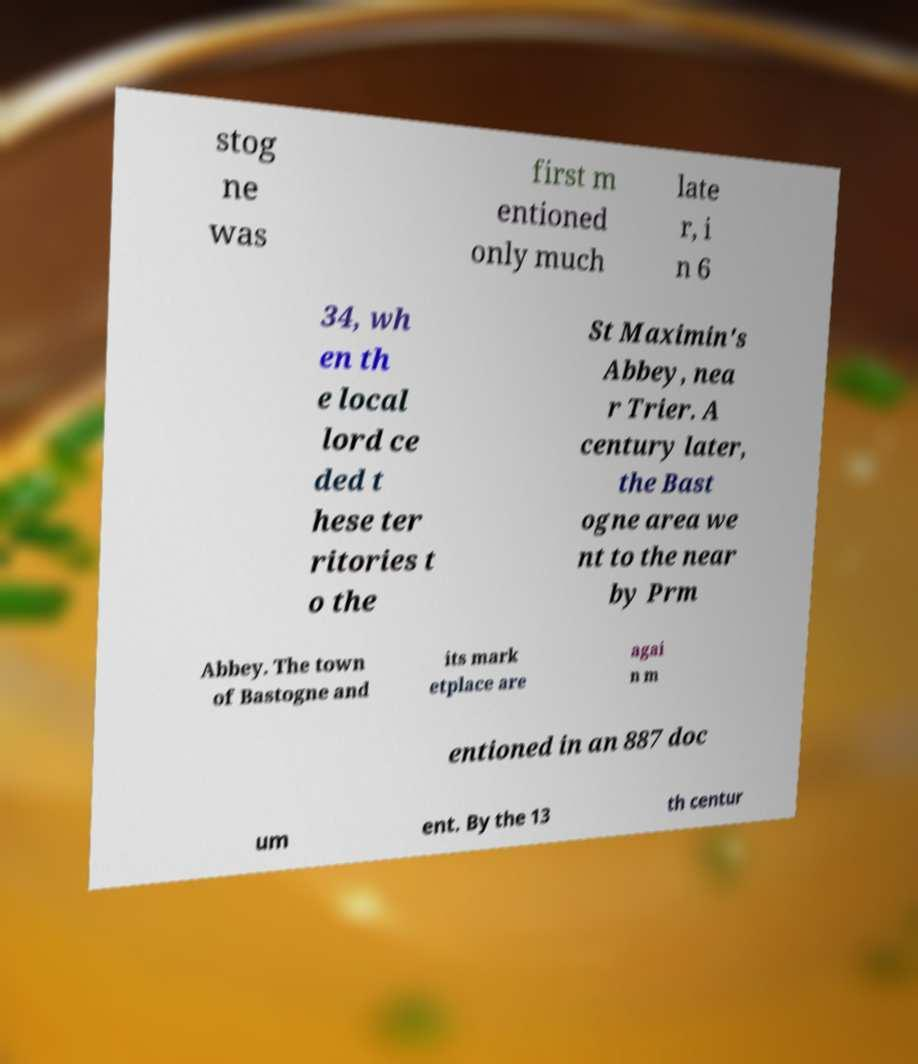Can you read and provide the text displayed in the image?This photo seems to have some interesting text. Can you extract and type it out for me? stog ne was first m entioned only much late r, i n 6 34, wh en th e local lord ce ded t hese ter ritories t o the St Maximin's Abbey, nea r Trier. A century later, the Bast ogne area we nt to the near by Prm Abbey. The town of Bastogne and its mark etplace are agai n m entioned in an 887 doc um ent. By the 13 th centur 